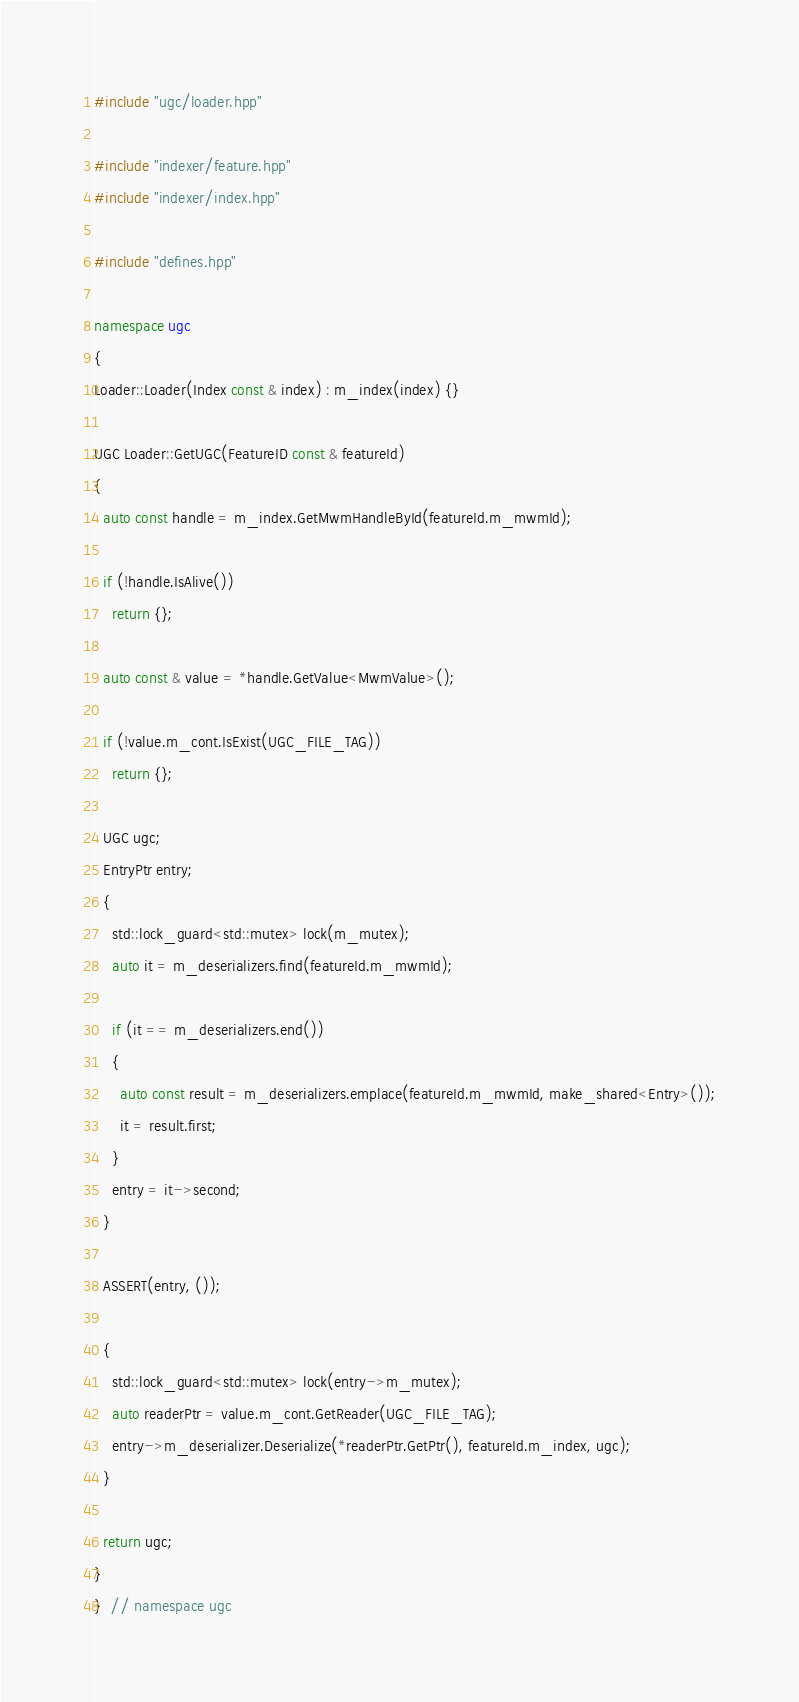<code> <loc_0><loc_0><loc_500><loc_500><_C++_>#include "ugc/loader.hpp"

#include "indexer/feature.hpp"
#include "indexer/index.hpp"

#include "defines.hpp"

namespace ugc
{
Loader::Loader(Index const & index) : m_index(index) {}

UGC Loader::GetUGC(FeatureID const & featureId)
{
  auto const handle = m_index.GetMwmHandleById(featureId.m_mwmId);

  if (!handle.IsAlive())
    return {};

  auto const & value = *handle.GetValue<MwmValue>();

  if (!value.m_cont.IsExist(UGC_FILE_TAG))
    return {};

  UGC ugc;
  EntryPtr entry;
  {
    std::lock_guard<std::mutex> lock(m_mutex);
    auto it = m_deserializers.find(featureId.m_mwmId);

    if (it == m_deserializers.end())
    {
      auto const result = m_deserializers.emplace(featureId.m_mwmId, make_shared<Entry>());
      it = result.first;
    }
    entry = it->second;
  }

  ASSERT(entry, ());

  {
    std::lock_guard<std::mutex> lock(entry->m_mutex);
    auto readerPtr = value.m_cont.GetReader(UGC_FILE_TAG);
    entry->m_deserializer.Deserialize(*readerPtr.GetPtr(), featureId.m_index, ugc);
  }

  return ugc;
}
}  // namespace ugc
</code> 